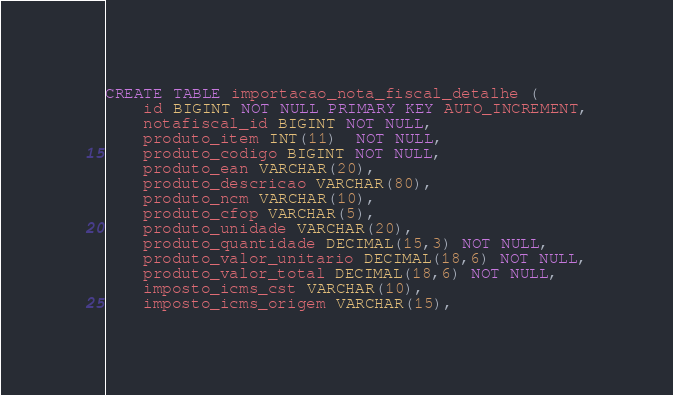<code> <loc_0><loc_0><loc_500><loc_500><_SQL_>CREATE TABLE importacao_nota_fiscal_detalhe (
    id BIGINT NOT NULL PRIMARY KEY AUTO_INCREMENT,
    notafiscal_id BIGINT NOT NULL,
    produto_item INT(11)  NOT NULL,
    produto_codigo BIGINT NOT NULL,
    produto_ean VARCHAR(20),
    produto_descricao VARCHAR(80),
    produto_ncm VARCHAR(10),
    produto_cfop VARCHAR(5),
    produto_unidade VARCHAR(20),
    produto_quantidade DECIMAL(15,3) NOT NULL,
    produto_valor_unitario DECIMAL(18,6) NOT NULL,
    produto_valor_total DECIMAL(18,6) NOT NULL,
    imposto_icms_cst VARCHAR(10),
    imposto_icms_origem VARCHAR(15),</code> 